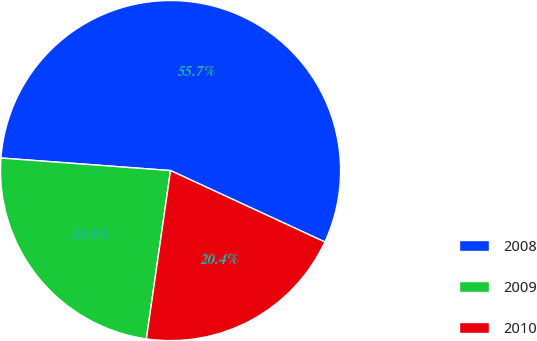<chart> <loc_0><loc_0><loc_500><loc_500><pie_chart><fcel>2008<fcel>2009<fcel>2010<nl><fcel>55.72%<fcel>23.91%<fcel>20.37%<nl></chart> 